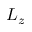<formula> <loc_0><loc_0><loc_500><loc_500>L _ { z }</formula> 